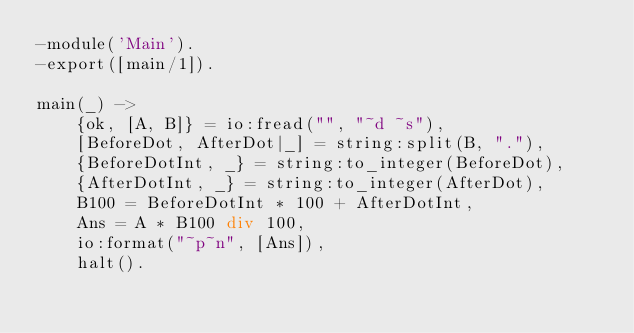Convert code to text. <code><loc_0><loc_0><loc_500><loc_500><_Erlang_>-module('Main').
-export([main/1]).

main(_) ->
    {ok, [A, B]} = io:fread("", "~d ~s"),
    [BeforeDot, AfterDot|_] = string:split(B, "."),
    {BeforeDotInt, _} = string:to_integer(BeforeDot),
    {AfterDotInt, _} = string:to_integer(AfterDot),
    B100 = BeforeDotInt * 100 + AfterDotInt,
    Ans = A * B100 div 100,
    io:format("~p~n", [Ans]),
    halt().</code> 